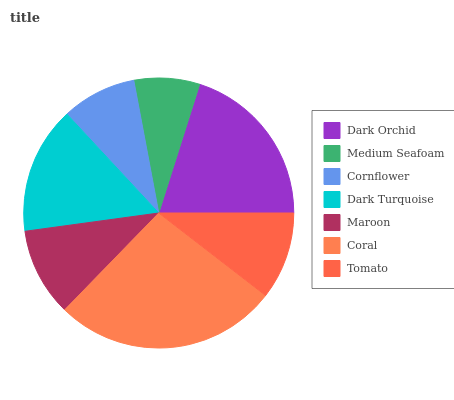Is Medium Seafoam the minimum?
Answer yes or no. Yes. Is Coral the maximum?
Answer yes or no. Yes. Is Cornflower the minimum?
Answer yes or no. No. Is Cornflower the maximum?
Answer yes or no. No. Is Cornflower greater than Medium Seafoam?
Answer yes or no. Yes. Is Medium Seafoam less than Cornflower?
Answer yes or no. Yes. Is Medium Seafoam greater than Cornflower?
Answer yes or no. No. Is Cornflower less than Medium Seafoam?
Answer yes or no. No. Is Maroon the high median?
Answer yes or no. Yes. Is Maroon the low median?
Answer yes or no. Yes. Is Cornflower the high median?
Answer yes or no. No. Is Cornflower the low median?
Answer yes or no. No. 